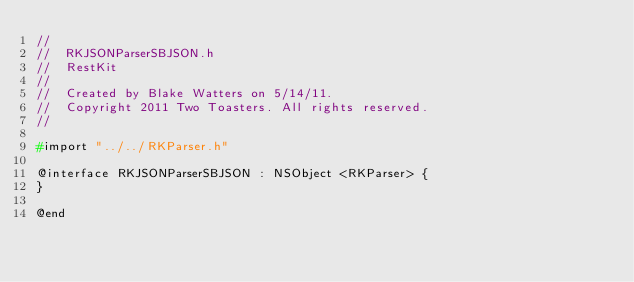<code> <loc_0><loc_0><loc_500><loc_500><_C_>//
//  RKJSONParserSBJSON.h
//  RestKit
//
//  Created by Blake Watters on 5/14/11.
//  Copyright 2011 Two Toasters. All rights reserved.
//

#import "../../RKParser.h"

@interface RKJSONParserSBJSON : NSObject <RKParser> {
}

@end
</code> 